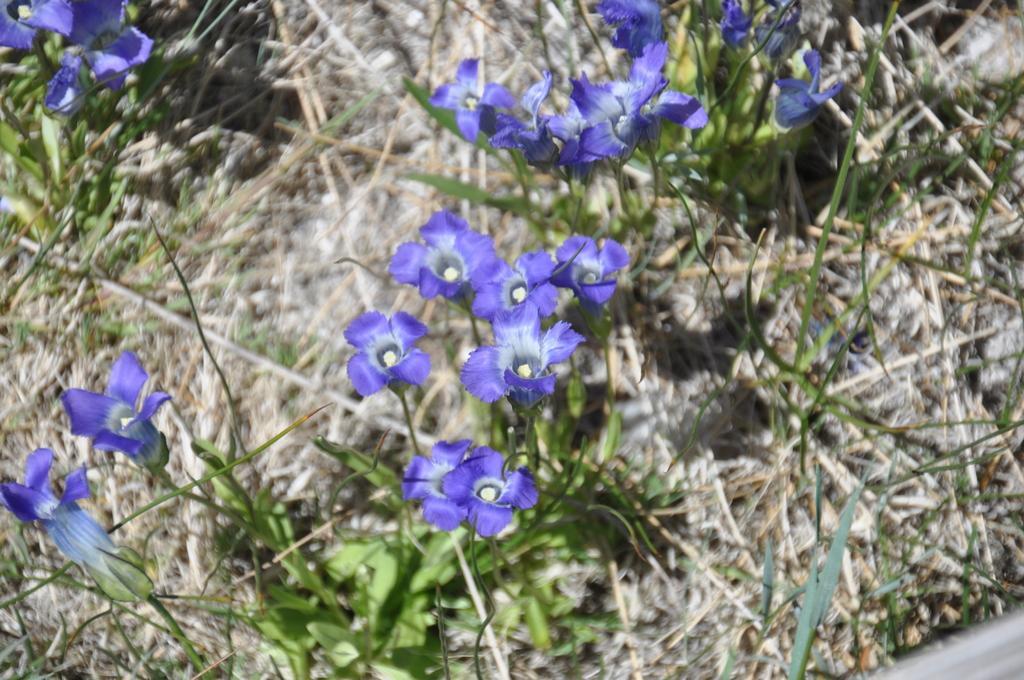Describe this image in one or two sentences. In this image, we can see some flowers and there is grass. 